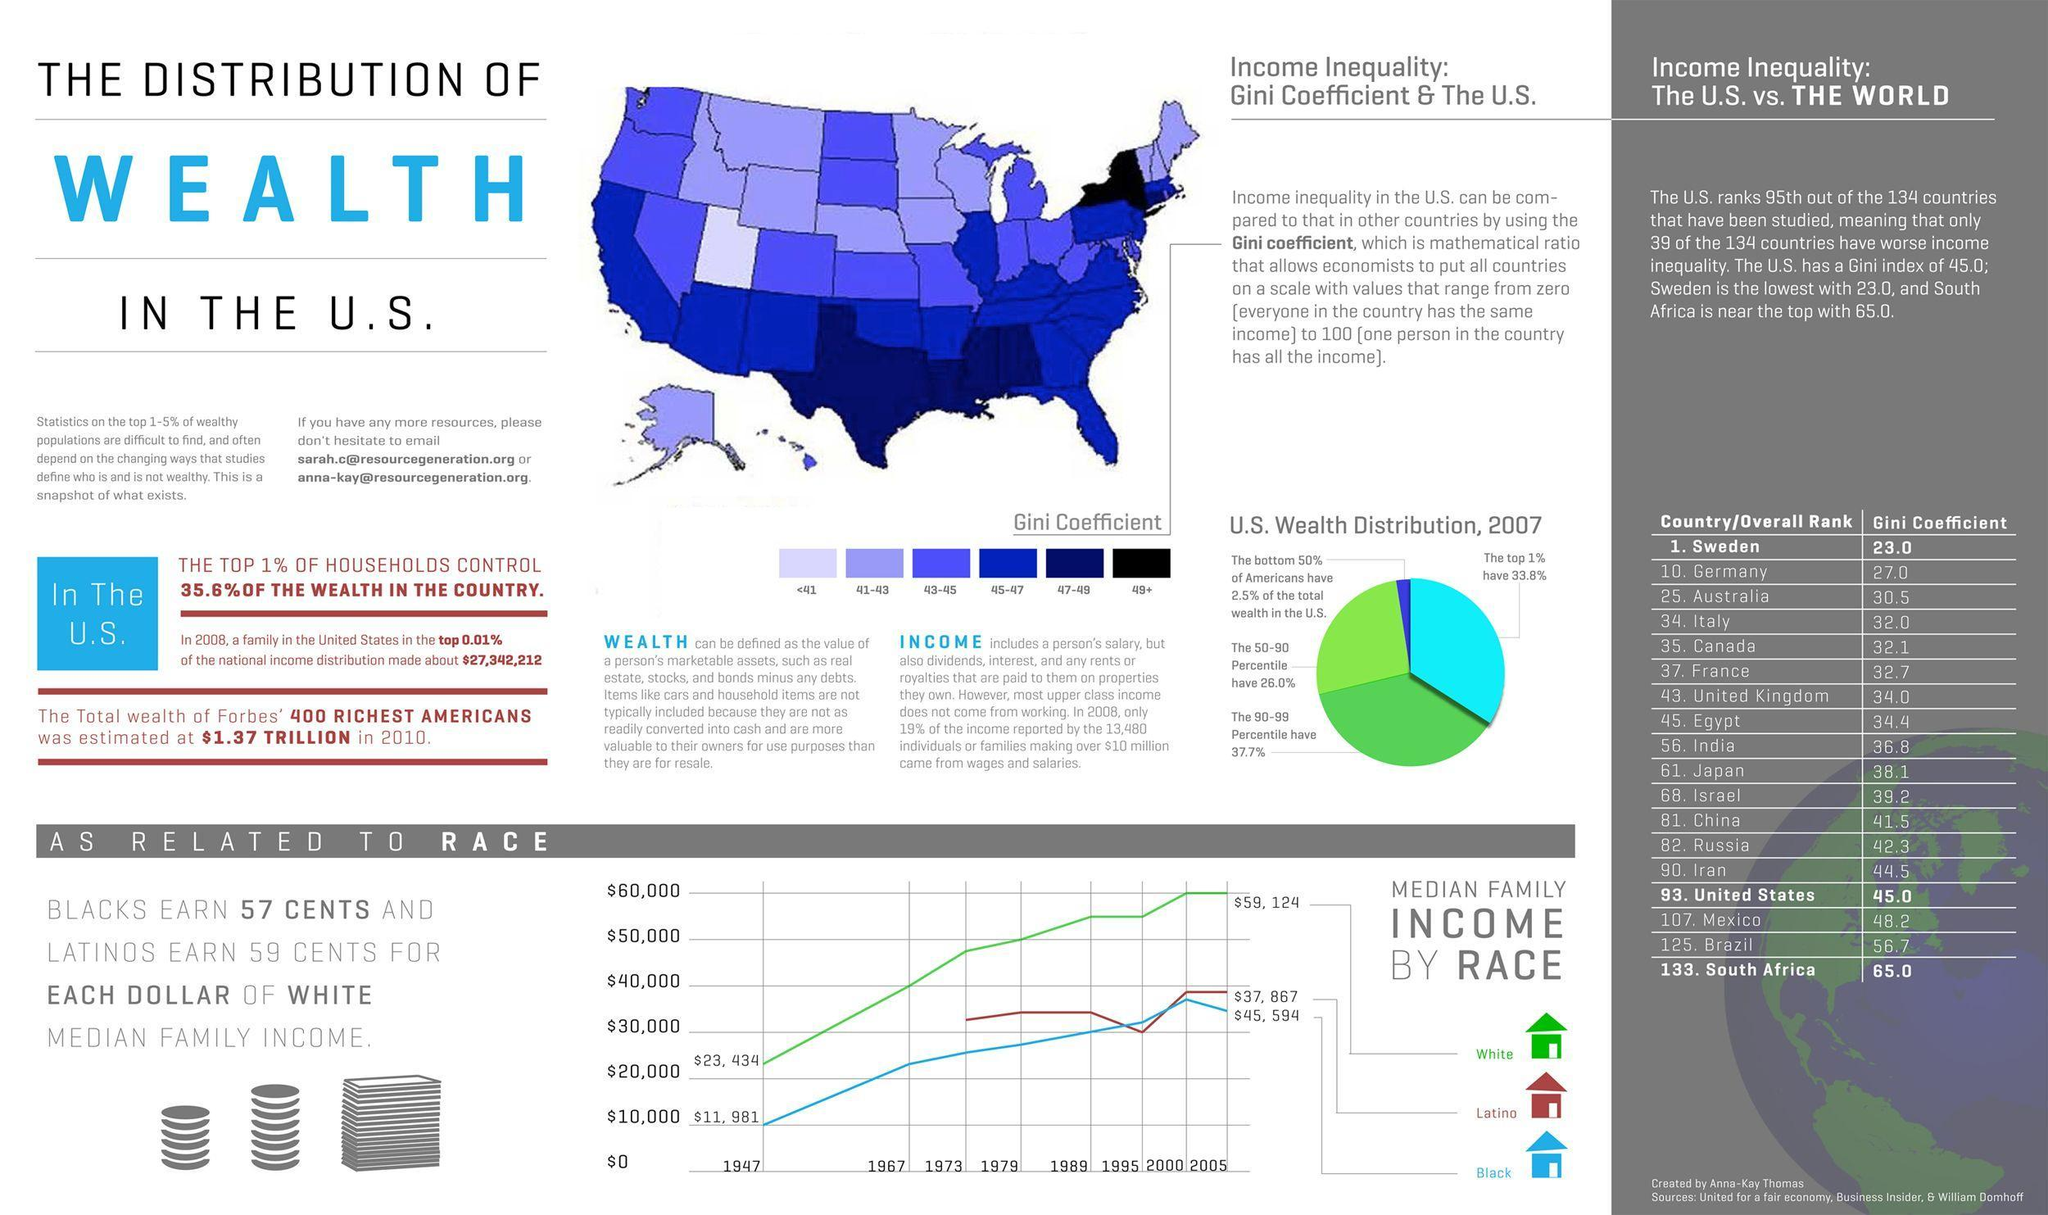What is the median family income of whites in 1967?
Answer the question with a short phrase. $40,000 How many countries have worse income inequality than Iran out of the 134 countries that have been studied? 44 What is the increase in median family income of Black from 1947 to 2005? $33,613 What is the increase in median family income of whites from 1947 to 2005? $35,690 How many countries have worse income inequality than South Africa out of the 134 countries that have been studied? 1 Which country has the tenth lowest Gini coefficient out of the 134 countries that have been studied? Germany How many countries have worse income inequality than Brazil out of the 134 countries that have been studied? 9 How many countries have worse income inequality than Canada out of the 134 countries that have been studied? 99 